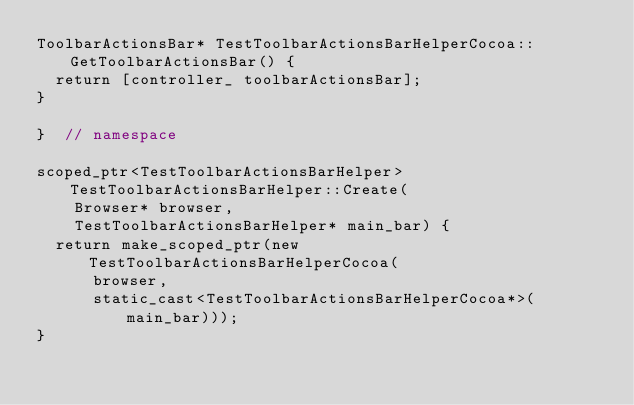Convert code to text. <code><loc_0><loc_0><loc_500><loc_500><_ObjectiveC_>ToolbarActionsBar* TestToolbarActionsBarHelperCocoa::GetToolbarActionsBar() {
  return [controller_ toolbarActionsBar];
}

}  // namespace

scoped_ptr<TestToolbarActionsBarHelper> TestToolbarActionsBarHelper::Create(
    Browser* browser,
    TestToolbarActionsBarHelper* main_bar) {
  return make_scoped_ptr(new TestToolbarActionsBarHelperCocoa(
      browser,
      static_cast<TestToolbarActionsBarHelperCocoa*>(main_bar)));
}
</code> 